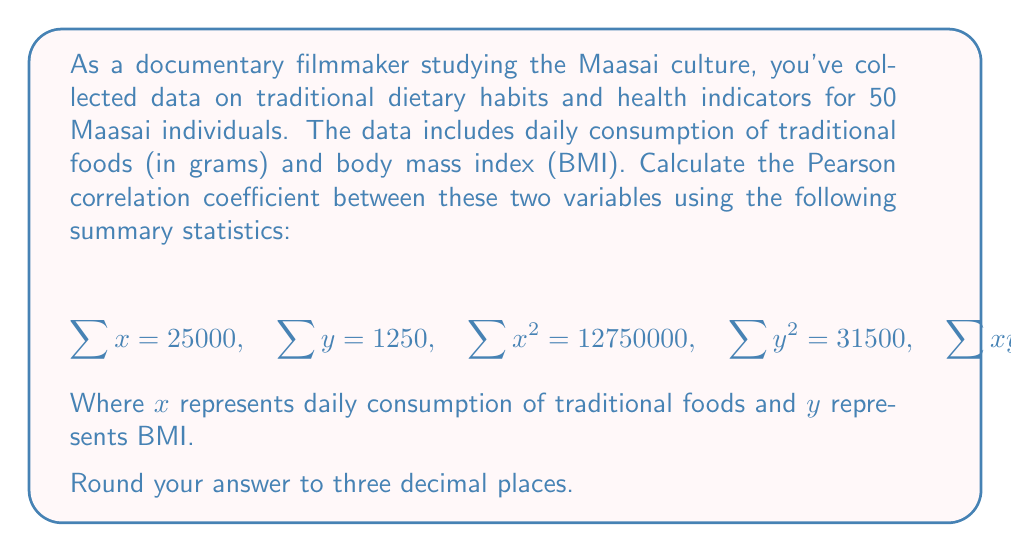Can you answer this question? To calculate the Pearson correlation coefficient, we'll use the formula:

$$r = \frac{n\sum xy - \sum x \sum y}{\sqrt{[n\sum x^2 - (\sum x)^2][n\sum y^2 - (\sum y)^2]}}$$

Where $n$ is the number of individuals (50 in this case).

Step 1: Calculate $n\sum xy$
$$n\sum xy = 50 \times 630000 = 31500000$$

Step 2: Calculate $\sum x \sum y$
$$\sum x \sum y = 25000 \times 1250 = 31250000$$

Step 3: Calculate the numerator
$$31500000 - 31250000 = 250000$$

Step 4: Calculate $n\sum x^2$ and $(\sum x)^2$
$$n\sum x^2 = 50 \times 12750000 = 637500000$$
$$(\sum x)^2 = 25000^2 = 625000000$$

Step 5: Calculate $n\sum y^2$ and $(\sum y)^2$
$$n\sum y^2 = 50 \times 31500 = 1575000$$
$$(\sum y)^2 = 1250^2 = 1562500$$

Step 6: Calculate the denominator
$$\sqrt{(637500000 - 625000000)(1575000 - 1562500)}$$
$$= \sqrt{(12500000)(12500)}$$
$$= \sqrt{156250000000}$$
$$= 395284.71$$

Step 7: Divide the numerator by the denominator
$$r = \frac{250000}{395284.71} = 0.632$$

Therefore, the Pearson correlation coefficient rounded to three decimal places is 0.632.
Answer: 0.632 